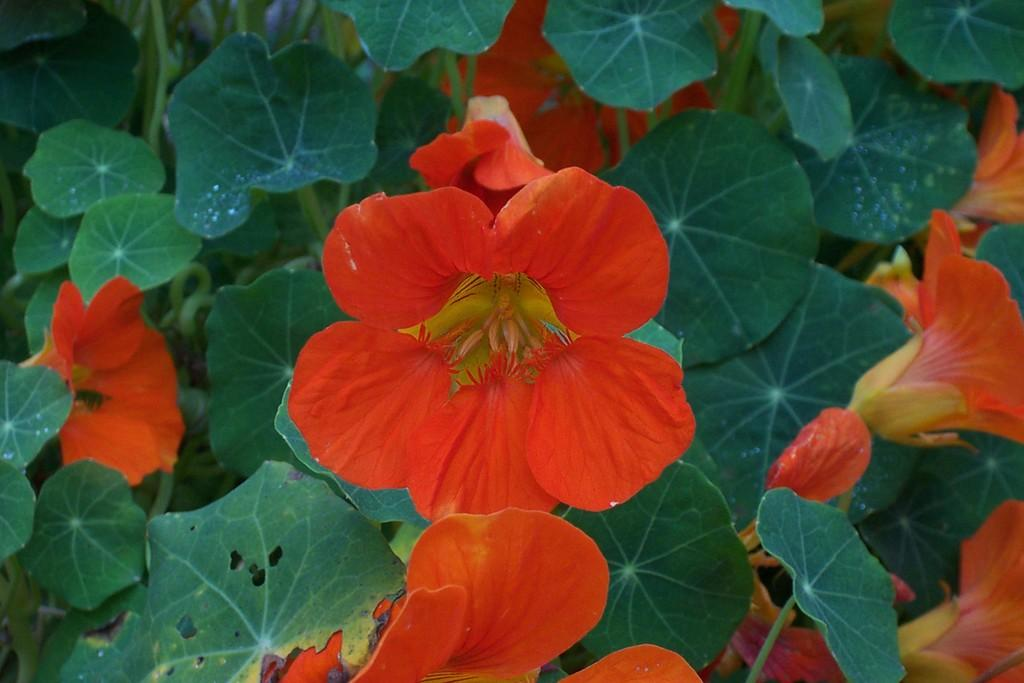What type of living organisms can be seen in the image? Plants and flowers are visible in the image. Can you describe the flowers in the image? The flowers in the image are part of the plants. Is there a person holding a bone and a kettle in the image? There is no person, bone, or kettle present in the image; it only features plants and flowers. 